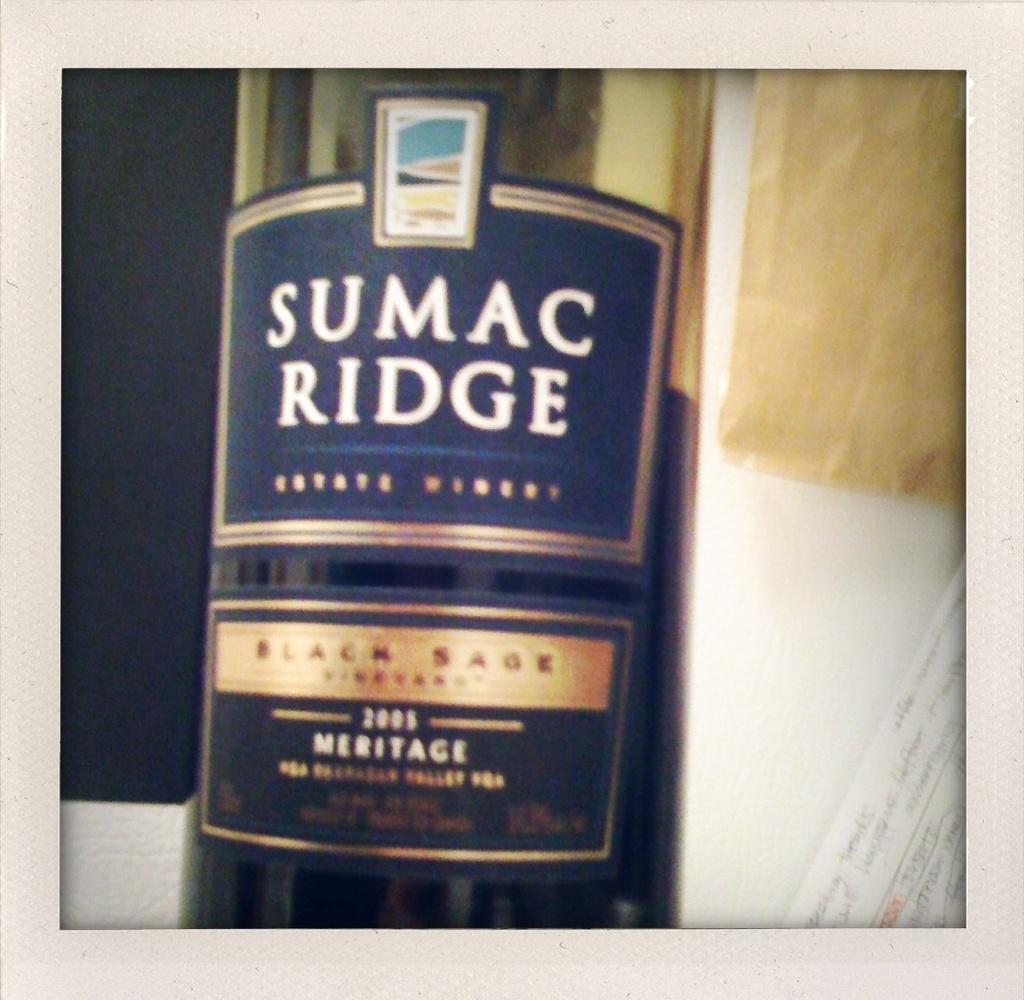What brand name is this wine?
Keep it short and to the point. Sumac ridge. 